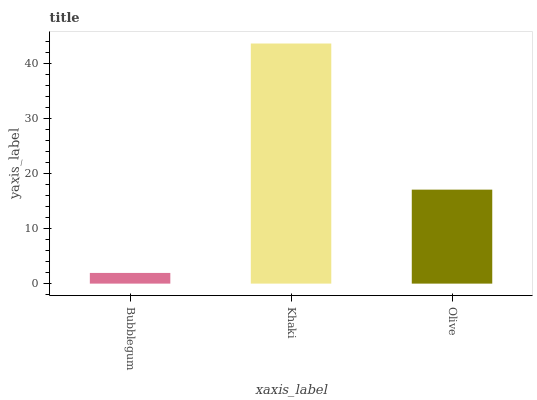Is Bubblegum the minimum?
Answer yes or no. Yes. Is Khaki the maximum?
Answer yes or no. Yes. Is Olive the minimum?
Answer yes or no. No. Is Olive the maximum?
Answer yes or no. No. Is Khaki greater than Olive?
Answer yes or no. Yes. Is Olive less than Khaki?
Answer yes or no. Yes. Is Olive greater than Khaki?
Answer yes or no. No. Is Khaki less than Olive?
Answer yes or no. No. Is Olive the high median?
Answer yes or no. Yes. Is Olive the low median?
Answer yes or no. Yes. Is Khaki the high median?
Answer yes or no. No. Is Khaki the low median?
Answer yes or no. No. 